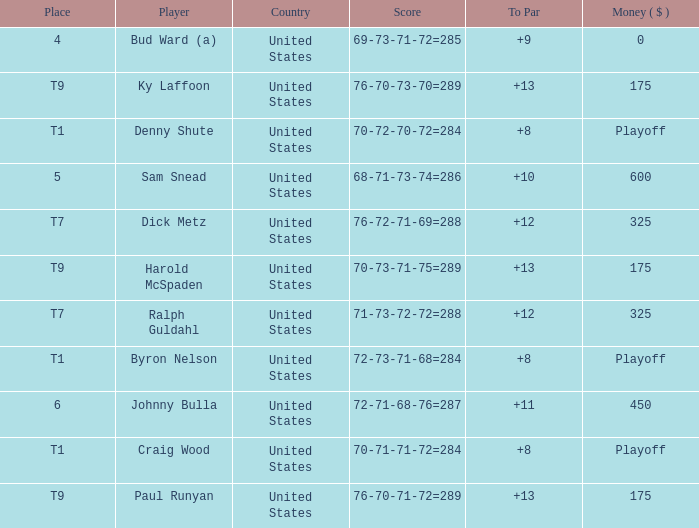What's the money that Sam Snead won? 600.0. 